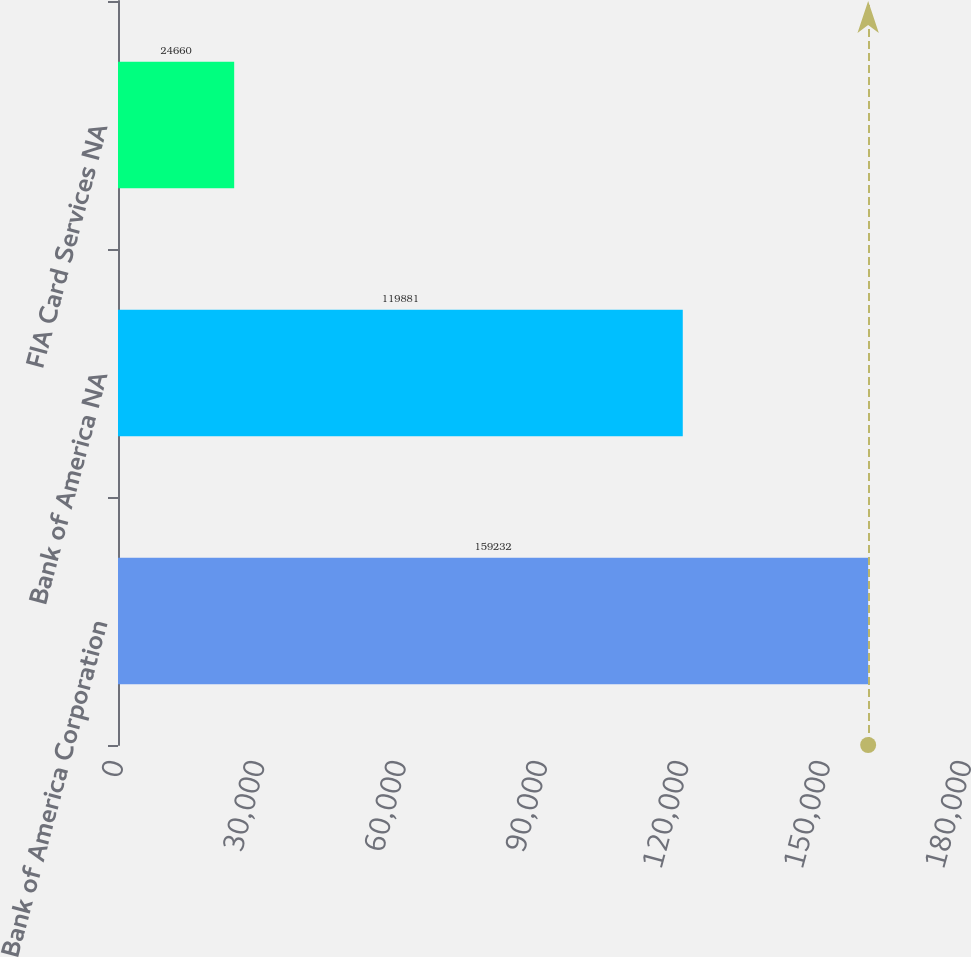Convert chart to OTSL. <chart><loc_0><loc_0><loc_500><loc_500><bar_chart><fcel>Bank of America Corporation<fcel>Bank of America NA<fcel>FIA Card Services NA<nl><fcel>159232<fcel>119881<fcel>24660<nl></chart> 